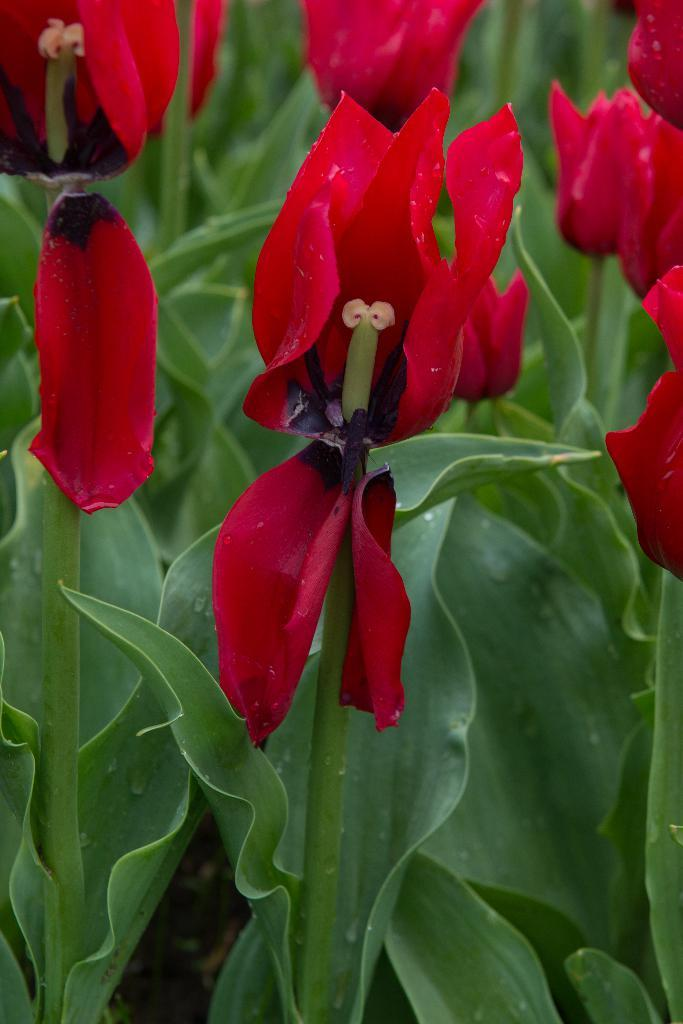What type of living organisms can be seen in the image? There are flowers and plants in the image. Can you describe the plants in the image? The plants in the image are not specified, but they are present alongside the flowers. What arithmetic problem is being solved by the flowers in the image? There is no arithmetic problem being solved by the flowers in the image, as flowers are not capable of performing arithmetic. 